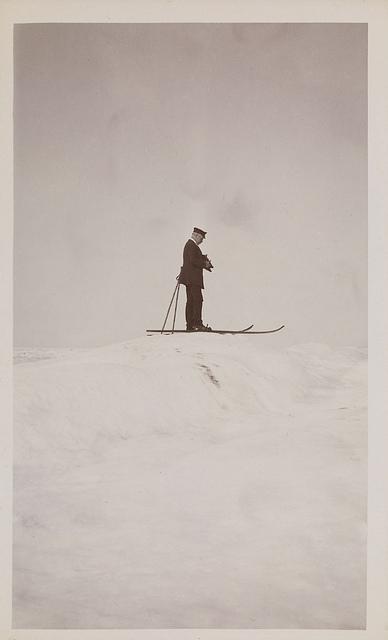Where is the man?
Quick response, please. Skiing. Is this photograph in color?
Answer briefly. No. Where is this photo taken?
Short answer required. Mountain. Is this man walking with a surfboard?
Keep it brief. No. What is this guy doing?
Give a very brief answer. Skiing. What is the person riding?
Concise answer only. Skis. What is in the picture?
Be succinct. Skier. How many ski poles do you see?
Be succinct. 2. 